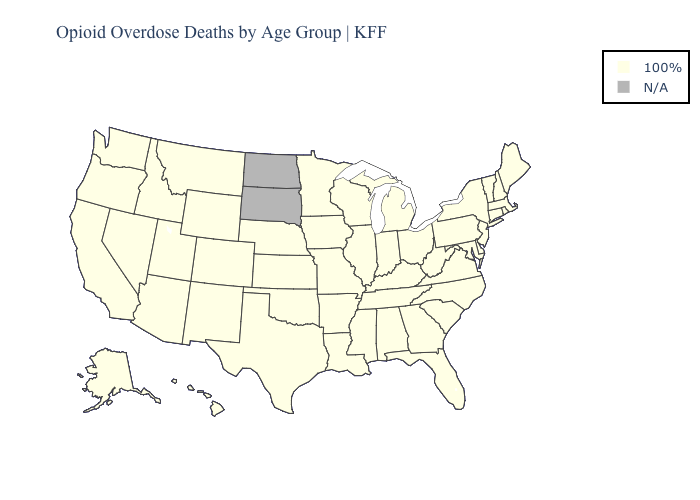What is the value of California?
Keep it brief. 100%. Among the states that border Illinois , which have the highest value?
Quick response, please. Indiana, Iowa, Kentucky, Missouri, Wisconsin. Which states hav the highest value in the Northeast?
Quick response, please. Connecticut, Maine, Massachusetts, New Hampshire, New Jersey, New York, Pennsylvania, Rhode Island, Vermont. What is the lowest value in the USA?
Concise answer only. 100%. What is the highest value in the USA?
Give a very brief answer. 100%. Name the states that have a value in the range 100%?
Answer briefly. Alabama, Alaska, Arizona, Arkansas, California, Colorado, Connecticut, Delaware, Florida, Georgia, Hawaii, Idaho, Illinois, Indiana, Iowa, Kansas, Kentucky, Louisiana, Maine, Maryland, Massachusetts, Michigan, Minnesota, Mississippi, Missouri, Montana, Nebraska, Nevada, New Hampshire, New Jersey, New Mexico, New York, North Carolina, Ohio, Oklahoma, Oregon, Pennsylvania, Rhode Island, South Carolina, Tennessee, Texas, Utah, Vermont, Virginia, Washington, West Virginia, Wisconsin, Wyoming. How many symbols are there in the legend?
Short answer required. 2. Name the states that have a value in the range 100%?
Write a very short answer. Alabama, Alaska, Arizona, Arkansas, California, Colorado, Connecticut, Delaware, Florida, Georgia, Hawaii, Idaho, Illinois, Indiana, Iowa, Kansas, Kentucky, Louisiana, Maine, Maryland, Massachusetts, Michigan, Minnesota, Mississippi, Missouri, Montana, Nebraska, Nevada, New Hampshire, New Jersey, New Mexico, New York, North Carolina, Ohio, Oklahoma, Oregon, Pennsylvania, Rhode Island, South Carolina, Tennessee, Texas, Utah, Vermont, Virginia, Washington, West Virginia, Wisconsin, Wyoming. What is the highest value in the USA?
Quick response, please. 100%. What is the value of California?
Give a very brief answer. 100%. Name the states that have a value in the range 100%?
Quick response, please. Alabama, Alaska, Arizona, Arkansas, California, Colorado, Connecticut, Delaware, Florida, Georgia, Hawaii, Idaho, Illinois, Indiana, Iowa, Kansas, Kentucky, Louisiana, Maine, Maryland, Massachusetts, Michigan, Minnesota, Mississippi, Missouri, Montana, Nebraska, Nevada, New Hampshire, New Jersey, New Mexico, New York, North Carolina, Ohio, Oklahoma, Oregon, Pennsylvania, Rhode Island, South Carolina, Tennessee, Texas, Utah, Vermont, Virginia, Washington, West Virginia, Wisconsin, Wyoming. What is the value of California?
Keep it brief. 100%. 